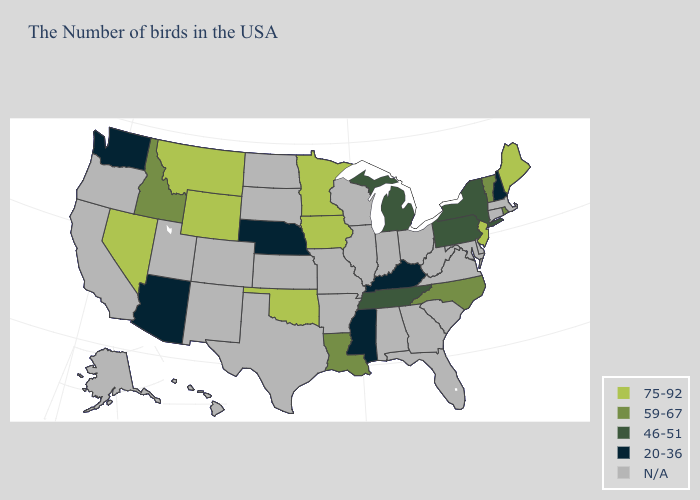What is the highest value in the USA?
Give a very brief answer. 75-92. What is the value of Arizona?
Be succinct. 20-36. What is the value of Illinois?
Quick response, please. N/A. Name the states that have a value in the range 75-92?
Be succinct. Maine, New Jersey, Minnesota, Iowa, Oklahoma, Wyoming, Montana, Nevada. What is the value of Arizona?
Write a very short answer. 20-36. What is the value of Mississippi?
Be succinct. 20-36. Name the states that have a value in the range 20-36?
Give a very brief answer. New Hampshire, Kentucky, Mississippi, Nebraska, Arizona, Washington. Which states have the lowest value in the USA?
Give a very brief answer. New Hampshire, Kentucky, Mississippi, Nebraska, Arizona, Washington. What is the value of Connecticut?
Give a very brief answer. N/A. Does Nevada have the lowest value in the West?
Concise answer only. No. Among the states that border Ohio , does Michigan have the highest value?
Short answer required. Yes. What is the value of Tennessee?
Keep it brief. 46-51. Does Nevada have the lowest value in the USA?
Write a very short answer. No. Among the states that border Massachusetts , does New Hampshire have the highest value?
Keep it brief. No. 